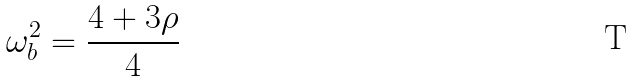<formula> <loc_0><loc_0><loc_500><loc_500>\omega _ { b } ^ { 2 } = \frac { 4 + 3 \rho } { 4 }</formula> 